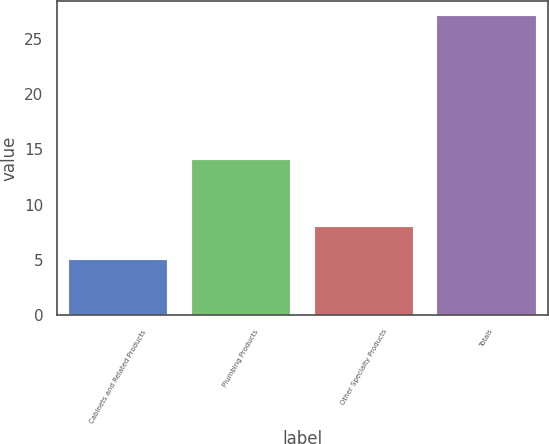Convert chart to OTSL. <chart><loc_0><loc_0><loc_500><loc_500><bar_chart><fcel>Cabinets and Related Products<fcel>Plumbing Products<fcel>Other Specialty Products<fcel>Totals<nl><fcel>5<fcel>14<fcel>8<fcel>27<nl></chart> 